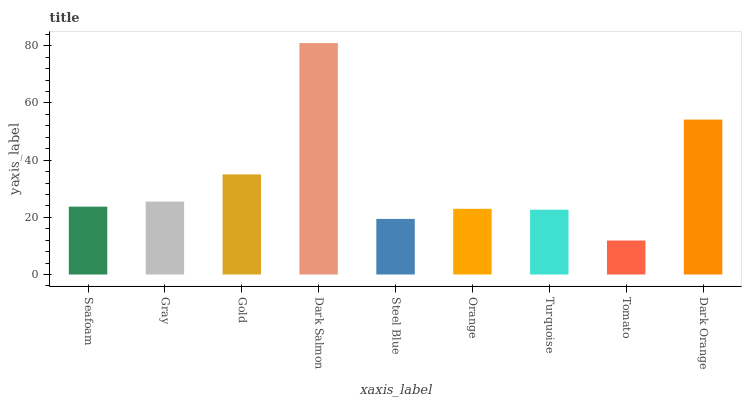Is Tomato the minimum?
Answer yes or no. Yes. Is Dark Salmon the maximum?
Answer yes or no. Yes. Is Gray the minimum?
Answer yes or no. No. Is Gray the maximum?
Answer yes or no. No. Is Gray greater than Seafoam?
Answer yes or no. Yes. Is Seafoam less than Gray?
Answer yes or no. Yes. Is Seafoam greater than Gray?
Answer yes or no. No. Is Gray less than Seafoam?
Answer yes or no. No. Is Seafoam the high median?
Answer yes or no. Yes. Is Seafoam the low median?
Answer yes or no. Yes. Is Turquoise the high median?
Answer yes or no. No. Is Turquoise the low median?
Answer yes or no. No. 